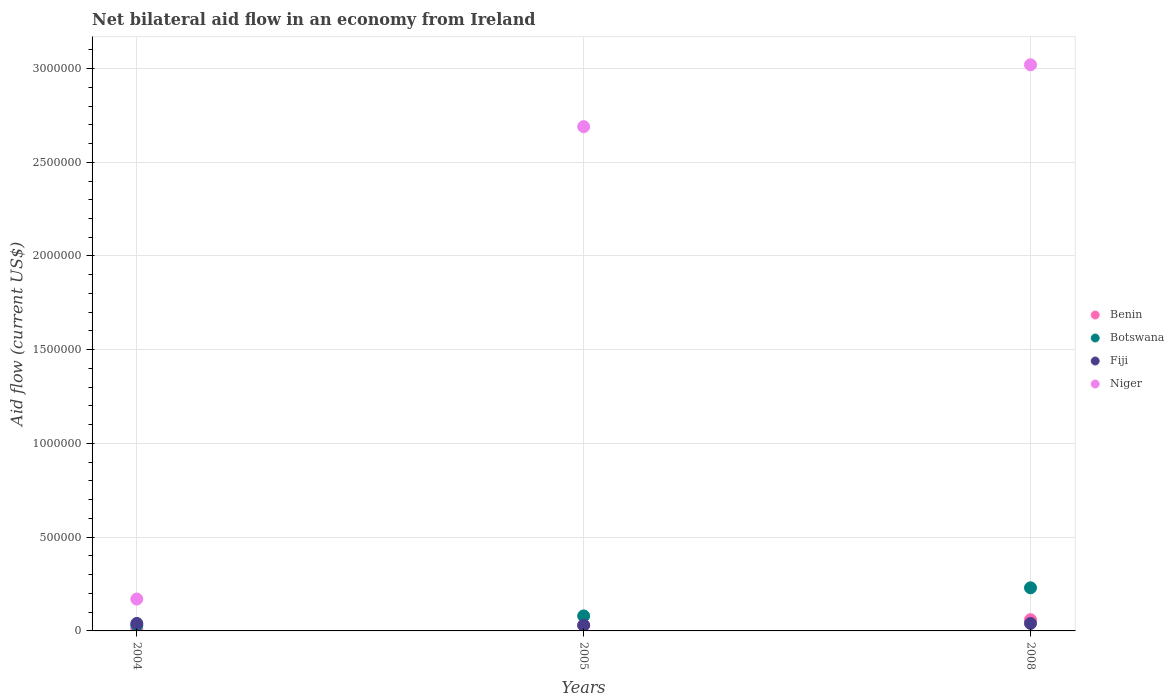How many different coloured dotlines are there?
Keep it short and to the point. 4. What is the net bilateral aid flow in Niger in 2008?
Your answer should be compact. 3.02e+06. In which year was the net bilateral aid flow in Fiji minimum?
Offer a very short reply. 2005. What is the total net bilateral aid flow in Niger in the graph?
Make the answer very short. 5.88e+06. What is the difference between the net bilateral aid flow in Benin in 2004 and the net bilateral aid flow in Botswana in 2008?
Offer a terse response. -2.20e+05. What is the average net bilateral aid flow in Fiji per year?
Ensure brevity in your answer.  3.67e+04. In how many years, is the net bilateral aid flow in Benin greater than 2500000 US$?
Keep it short and to the point. 0. What is the ratio of the net bilateral aid flow in Benin in 2004 to that in 2005?
Make the answer very short. 0.33. What is the difference between the highest and the second highest net bilateral aid flow in Niger?
Give a very brief answer. 3.30e+05. In how many years, is the net bilateral aid flow in Fiji greater than the average net bilateral aid flow in Fiji taken over all years?
Your answer should be compact. 2. Is it the case that in every year, the sum of the net bilateral aid flow in Botswana and net bilateral aid flow in Fiji  is greater than the sum of net bilateral aid flow in Benin and net bilateral aid flow in Niger?
Your answer should be compact. No. Is it the case that in every year, the sum of the net bilateral aid flow in Botswana and net bilateral aid flow in Niger  is greater than the net bilateral aid flow in Fiji?
Offer a terse response. Yes. Does the net bilateral aid flow in Benin monotonically increase over the years?
Provide a short and direct response. Yes. What is the difference between two consecutive major ticks on the Y-axis?
Offer a very short reply. 5.00e+05. Does the graph contain any zero values?
Make the answer very short. No. What is the title of the graph?
Ensure brevity in your answer.  Net bilateral aid flow in an economy from Ireland. Does "Paraguay" appear as one of the legend labels in the graph?
Your answer should be compact. No. What is the label or title of the X-axis?
Your answer should be compact. Years. What is the Aid flow (current US$) in Botswana in 2004?
Provide a short and direct response. 3.00e+04. What is the Aid flow (current US$) in Fiji in 2004?
Make the answer very short. 4.00e+04. What is the Aid flow (current US$) in Benin in 2005?
Offer a very short reply. 3.00e+04. What is the Aid flow (current US$) of Fiji in 2005?
Your response must be concise. 3.00e+04. What is the Aid flow (current US$) of Niger in 2005?
Make the answer very short. 2.69e+06. What is the Aid flow (current US$) of Niger in 2008?
Provide a short and direct response. 3.02e+06. Across all years, what is the maximum Aid flow (current US$) in Benin?
Offer a terse response. 6.00e+04. Across all years, what is the maximum Aid flow (current US$) in Niger?
Ensure brevity in your answer.  3.02e+06. Across all years, what is the minimum Aid flow (current US$) of Niger?
Ensure brevity in your answer.  1.70e+05. What is the total Aid flow (current US$) in Fiji in the graph?
Provide a short and direct response. 1.10e+05. What is the total Aid flow (current US$) in Niger in the graph?
Provide a succinct answer. 5.88e+06. What is the difference between the Aid flow (current US$) in Benin in 2004 and that in 2005?
Your answer should be compact. -2.00e+04. What is the difference between the Aid flow (current US$) of Botswana in 2004 and that in 2005?
Make the answer very short. -5.00e+04. What is the difference between the Aid flow (current US$) in Niger in 2004 and that in 2005?
Your response must be concise. -2.52e+06. What is the difference between the Aid flow (current US$) of Botswana in 2004 and that in 2008?
Give a very brief answer. -2.00e+05. What is the difference between the Aid flow (current US$) in Niger in 2004 and that in 2008?
Your answer should be compact. -2.85e+06. What is the difference between the Aid flow (current US$) in Benin in 2005 and that in 2008?
Provide a short and direct response. -3.00e+04. What is the difference between the Aid flow (current US$) in Botswana in 2005 and that in 2008?
Offer a terse response. -1.50e+05. What is the difference between the Aid flow (current US$) in Niger in 2005 and that in 2008?
Offer a terse response. -3.30e+05. What is the difference between the Aid flow (current US$) of Benin in 2004 and the Aid flow (current US$) of Niger in 2005?
Your answer should be compact. -2.68e+06. What is the difference between the Aid flow (current US$) of Botswana in 2004 and the Aid flow (current US$) of Niger in 2005?
Provide a succinct answer. -2.66e+06. What is the difference between the Aid flow (current US$) of Fiji in 2004 and the Aid flow (current US$) of Niger in 2005?
Make the answer very short. -2.65e+06. What is the difference between the Aid flow (current US$) in Benin in 2004 and the Aid flow (current US$) in Niger in 2008?
Offer a very short reply. -3.01e+06. What is the difference between the Aid flow (current US$) in Botswana in 2004 and the Aid flow (current US$) in Niger in 2008?
Ensure brevity in your answer.  -2.99e+06. What is the difference between the Aid flow (current US$) in Fiji in 2004 and the Aid flow (current US$) in Niger in 2008?
Your answer should be very brief. -2.98e+06. What is the difference between the Aid flow (current US$) in Benin in 2005 and the Aid flow (current US$) in Botswana in 2008?
Give a very brief answer. -2.00e+05. What is the difference between the Aid flow (current US$) in Benin in 2005 and the Aid flow (current US$) in Niger in 2008?
Keep it short and to the point. -2.99e+06. What is the difference between the Aid flow (current US$) in Botswana in 2005 and the Aid flow (current US$) in Niger in 2008?
Provide a short and direct response. -2.94e+06. What is the difference between the Aid flow (current US$) of Fiji in 2005 and the Aid flow (current US$) of Niger in 2008?
Your answer should be compact. -2.99e+06. What is the average Aid flow (current US$) of Benin per year?
Offer a very short reply. 3.33e+04. What is the average Aid flow (current US$) in Botswana per year?
Provide a short and direct response. 1.13e+05. What is the average Aid flow (current US$) of Fiji per year?
Offer a very short reply. 3.67e+04. What is the average Aid flow (current US$) in Niger per year?
Your answer should be compact. 1.96e+06. In the year 2004, what is the difference between the Aid flow (current US$) of Benin and Aid flow (current US$) of Botswana?
Offer a terse response. -2.00e+04. In the year 2004, what is the difference between the Aid flow (current US$) in Benin and Aid flow (current US$) in Fiji?
Offer a terse response. -3.00e+04. In the year 2004, what is the difference between the Aid flow (current US$) of Botswana and Aid flow (current US$) of Fiji?
Offer a very short reply. -10000. In the year 2004, what is the difference between the Aid flow (current US$) of Botswana and Aid flow (current US$) of Niger?
Your answer should be compact. -1.40e+05. In the year 2004, what is the difference between the Aid flow (current US$) in Fiji and Aid flow (current US$) in Niger?
Your answer should be compact. -1.30e+05. In the year 2005, what is the difference between the Aid flow (current US$) of Benin and Aid flow (current US$) of Botswana?
Offer a terse response. -5.00e+04. In the year 2005, what is the difference between the Aid flow (current US$) in Benin and Aid flow (current US$) in Niger?
Your answer should be very brief. -2.66e+06. In the year 2005, what is the difference between the Aid flow (current US$) in Botswana and Aid flow (current US$) in Fiji?
Your answer should be very brief. 5.00e+04. In the year 2005, what is the difference between the Aid flow (current US$) of Botswana and Aid flow (current US$) of Niger?
Provide a short and direct response. -2.61e+06. In the year 2005, what is the difference between the Aid flow (current US$) of Fiji and Aid flow (current US$) of Niger?
Give a very brief answer. -2.66e+06. In the year 2008, what is the difference between the Aid flow (current US$) of Benin and Aid flow (current US$) of Niger?
Your answer should be very brief. -2.96e+06. In the year 2008, what is the difference between the Aid flow (current US$) of Botswana and Aid flow (current US$) of Niger?
Ensure brevity in your answer.  -2.79e+06. In the year 2008, what is the difference between the Aid flow (current US$) in Fiji and Aid flow (current US$) in Niger?
Offer a very short reply. -2.98e+06. What is the ratio of the Aid flow (current US$) in Benin in 2004 to that in 2005?
Provide a succinct answer. 0.33. What is the ratio of the Aid flow (current US$) in Botswana in 2004 to that in 2005?
Make the answer very short. 0.38. What is the ratio of the Aid flow (current US$) in Fiji in 2004 to that in 2005?
Provide a short and direct response. 1.33. What is the ratio of the Aid flow (current US$) in Niger in 2004 to that in 2005?
Ensure brevity in your answer.  0.06. What is the ratio of the Aid flow (current US$) of Botswana in 2004 to that in 2008?
Offer a very short reply. 0.13. What is the ratio of the Aid flow (current US$) in Fiji in 2004 to that in 2008?
Provide a succinct answer. 1. What is the ratio of the Aid flow (current US$) in Niger in 2004 to that in 2008?
Keep it short and to the point. 0.06. What is the ratio of the Aid flow (current US$) of Benin in 2005 to that in 2008?
Make the answer very short. 0.5. What is the ratio of the Aid flow (current US$) in Botswana in 2005 to that in 2008?
Give a very brief answer. 0.35. What is the ratio of the Aid flow (current US$) of Niger in 2005 to that in 2008?
Your response must be concise. 0.89. What is the difference between the highest and the second highest Aid flow (current US$) in Fiji?
Offer a very short reply. 0. What is the difference between the highest and the lowest Aid flow (current US$) in Niger?
Keep it short and to the point. 2.85e+06. 